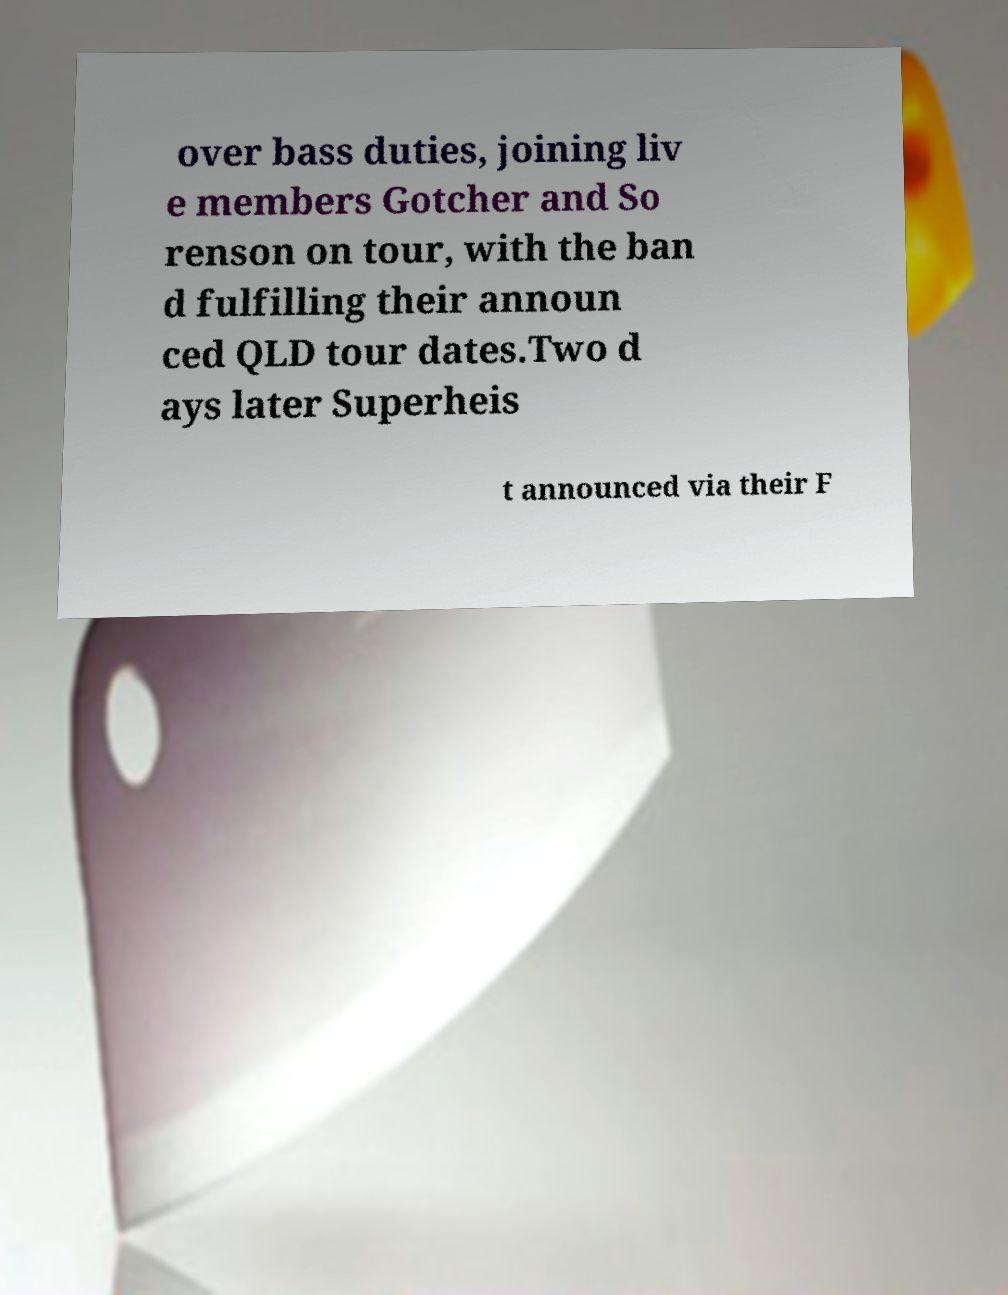Please read and relay the text visible in this image. What does it say? over bass duties, joining liv e members Gotcher and So renson on tour, with the ban d fulfilling their announ ced QLD tour dates.Two d ays later Superheis t announced via their F 